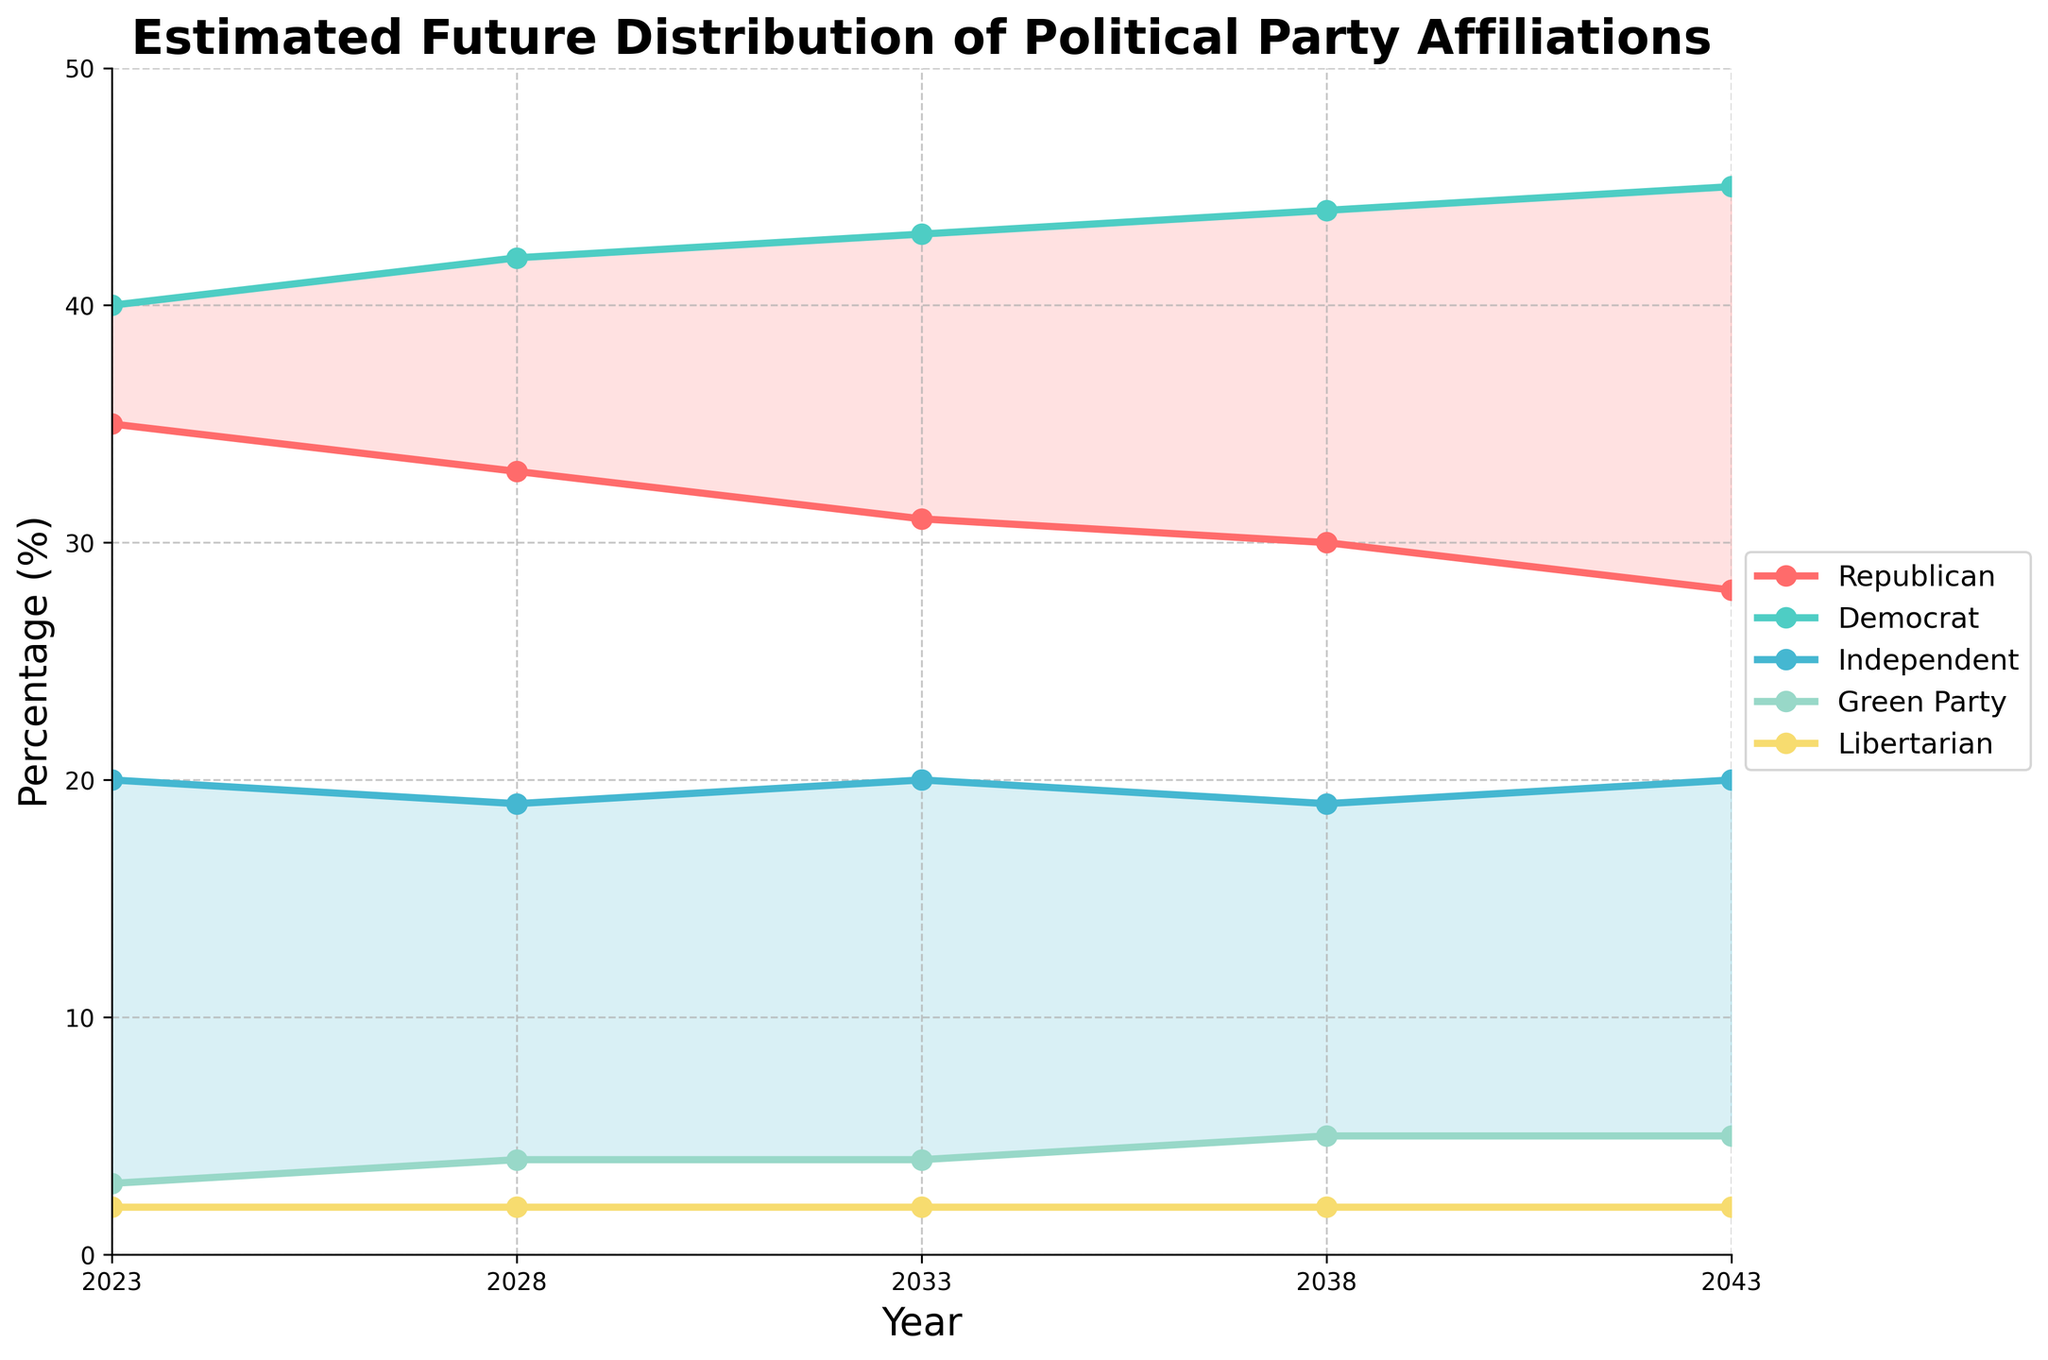What is the title of the figure? The title is usually located at the top of the figure and provides a summary of what the figure is about. The title in this case is "Estimated Future Distribution of Political Party Affiliations".
Answer: Estimated Future Distribution of Political Party Affiliations What color represents the Democrat party? The colors corresponding to each party are indicated in the legend. According to the legend, the Democrat party is represented by a teal color.
Answer: Teal How does the percentage of Republicans change from 2023 to 2043? By looking at the plotted line for Republicans (red color) on the y-axis and the corresponding years on the x-axis, we can observe the change. The percentage decreases from 35% in 2023 to 28% in 2043.
Answer: Decreases from 35% to 28% Which party shows the largest increase in percentage from 2023 to 2043? By comparing the changes in percentages of all parties over the given years, the Democrat party has the highest increase from 40% to 45%.
Answer: Democrat What is the percentage difference between Democrats and Republicans in 2033? To find this, we take the percentage of Democrats (43%) and subtract the percentage of Republicans (31%) for the year 2033. The difference is 43% - 31%.
Answer: 12% What percentage of the population is estimated to be Green Party affiliates in 2028? Looking at the Green Party line in the figure for the year 2028, the percentage is shown to be 4%.
Answer: 4% Which parties experience no change in their percentage from 2023 to 2043? By comparing the percentage values from 2023 to 2043 for all parties, the Libertarian party consistently remains at 2%.
Answer: Libertarian In what year do Independents reach 20% again after 2023? The percentage of Independents starts at 20% in 2023 and returns to 20% in the year 2033 and 2043, after dipping slightly.
Answer: 2033 What is the combined percentage of Green Party and Libertarian affiliates in 2043? We sum the percentages of Green Party (5%) and Libertarian (2%) in the year 2043. The combined percentage is 5% + 2%.
Answer: 7% How does the percentage of Independents compare to Green Party in 2028? By comparing the values of Independents (19%) and Green Party (4%) in 2028, Independents have a significantly higher percentage.
Answer: Higher 